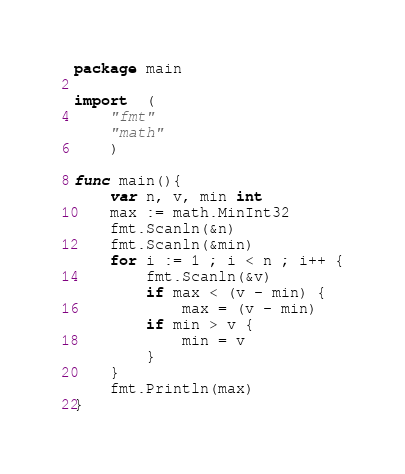Convert code to text. <code><loc_0><loc_0><loc_500><loc_500><_Go_>package main

import  (
    "fmt"
    "math"
    )

func main(){
    var n, v, min int
    max := math.MinInt32
    fmt.Scanln(&n)
    fmt.Scanln(&min)
    for i := 1 ; i < n ; i++ {
        fmt.Scanln(&v)
        if max < (v - min) {
            max = (v - min)
        if min > v {
            min = v
        }
    }
    fmt.Println(max)
}
</code> 